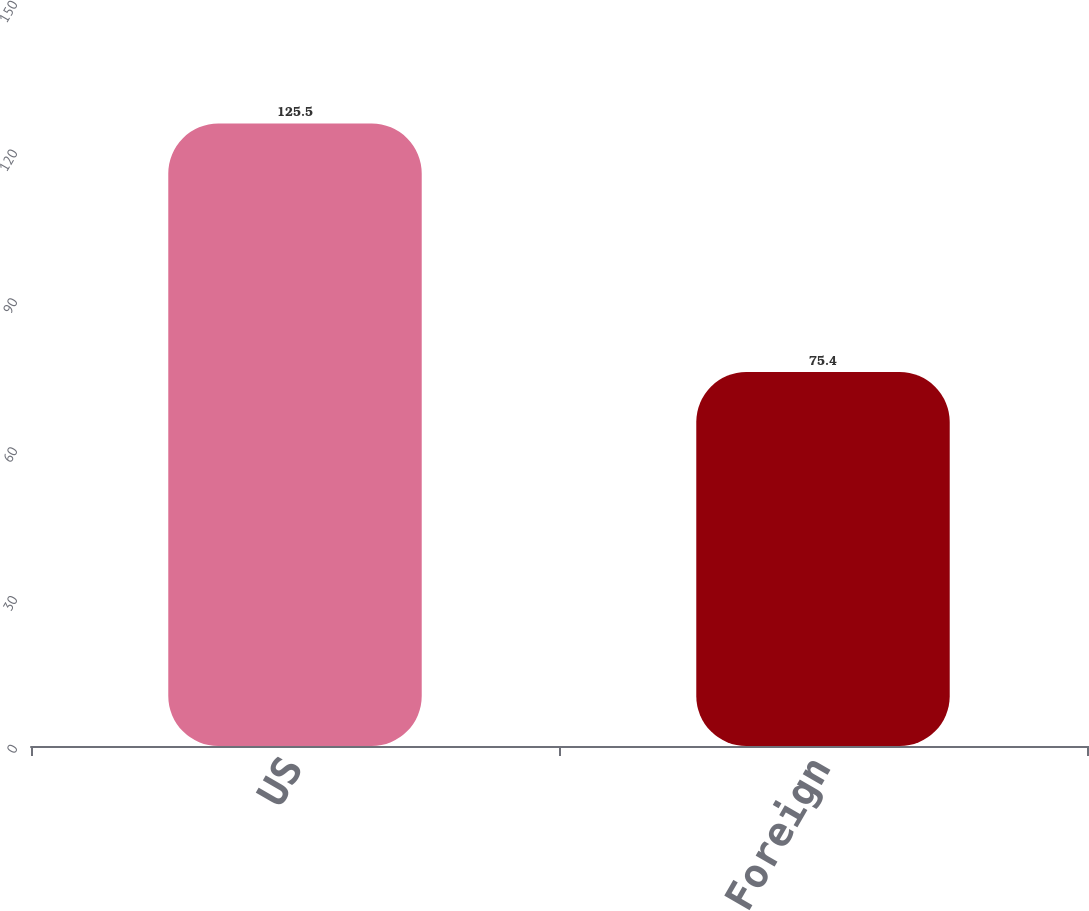<chart> <loc_0><loc_0><loc_500><loc_500><bar_chart><fcel>US<fcel>Foreign<nl><fcel>125.5<fcel>75.4<nl></chart> 